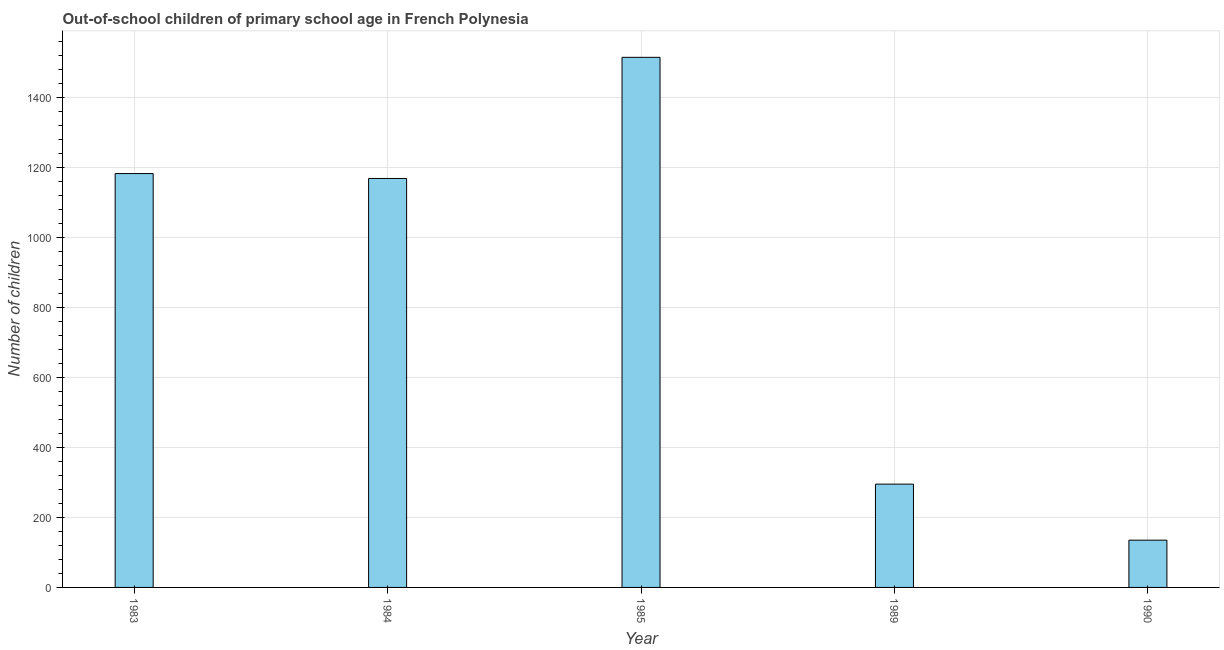What is the title of the graph?
Provide a succinct answer. Out-of-school children of primary school age in French Polynesia. What is the label or title of the X-axis?
Provide a short and direct response. Year. What is the label or title of the Y-axis?
Provide a succinct answer. Number of children. What is the number of out-of-school children in 1984?
Your answer should be very brief. 1168. Across all years, what is the maximum number of out-of-school children?
Give a very brief answer. 1514. Across all years, what is the minimum number of out-of-school children?
Keep it short and to the point. 135. In which year was the number of out-of-school children maximum?
Give a very brief answer. 1985. In which year was the number of out-of-school children minimum?
Provide a short and direct response. 1990. What is the sum of the number of out-of-school children?
Provide a short and direct response. 4294. What is the difference between the number of out-of-school children in 1983 and 1989?
Your answer should be compact. 887. What is the average number of out-of-school children per year?
Keep it short and to the point. 858. What is the median number of out-of-school children?
Your answer should be compact. 1168. Do a majority of the years between 1990 and 1985 (inclusive) have number of out-of-school children greater than 760 ?
Your answer should be compact. Yes. What is the ratio of the number of out-of-school children in 1983 to that in 1990?
Provide a succinct answer. 8.76. Is the number of out-of-school children in 1983 less than that in 1985?
Give a very brief answer. Yes. What is the difference between the highest and the second highest number of out-of-school children?
Offer a terse response. 332. What is the difference between the highest and the lowest number of out-of-school children?
Ensure brevity in your answer.  1379. In how many years, is the number of out-of-school children greater than the average number of out-of-school children taken over all years?
Keep it short and to the point. 3. How many years are there in the graph?
Offer a very short reply. 5. Are the values on the major ticks of Y-axis written in scientific E-notation?
Ensure brevity in your answer.  No. What is the Number of children in 1983?
Offer a very short reply. 1182. What is the Number of children in 1984?
Your answer should be compact. 1168. What is the Number of children in 1985?
Offer a very short reply. 1514. What is the Number of children in 1989?
Provide a short and direct response. 295. What is the Number of children in 1990?
Give a very brief answer. 135. What is the difference between the Number of children in 1983 and 1985?
Your answer should be compact. -332. What is the difference between the Number of children in 1983 and 1989?
Your response must be concise. 887. What is the difference between the Number of children in 1983 and 1990?
Provide a succinct answer. 1047. What is the difference between the Number of children in 1984 and 1985?
Offer a terse response. -346. What is the difference between the Number of children in 1984 and 1989?
Give a very brief answer. 873. What is the difference between the Number of children in 1984 and 1990?
Make the answer very short. 1033. What is the difference between the Number of children in 1985 and 1989?
Your answer should be very brief. 1219. What is the difference between the Number of children in 1985 and 1990?
Give a very brief answer. 1379. What is the difference between the Number of children in 1989 and 1990?
Provide a succinct answer. 160. What is the ratio of the Number of children in 1983 to that in 1985?
Your answer should be very brief. 0.78. What is the ratio of the Number of children in 1983 to that in 1989?
Provide a short and direct response. 4.01. What is the ratio of the Number of children in 1983 to that in 1990?
Keep it short and to the point. 8.76. What is the ratio of the Number of children in 1984 to that in 1985?
Your answer should be compact. 0.77. What is the ratio of the Number of children in 1984 to that in 1989?
Offer a terse response. 3.96. What is the ratio of the Number of children in 1984 to that in 1990?
Offer a very short reply. 8.65. What is the ratio of the Number of children in 1985 to that in 1989?
Ensure brevity in your answer.  5.13. What is the ratio of the Number of children in 1985 to that in 1990?
Give a very brief answer. 11.21. What is the ratio of the Number of children in 1989 to that in 1990?
Provide a short and direct response. 2.19. 